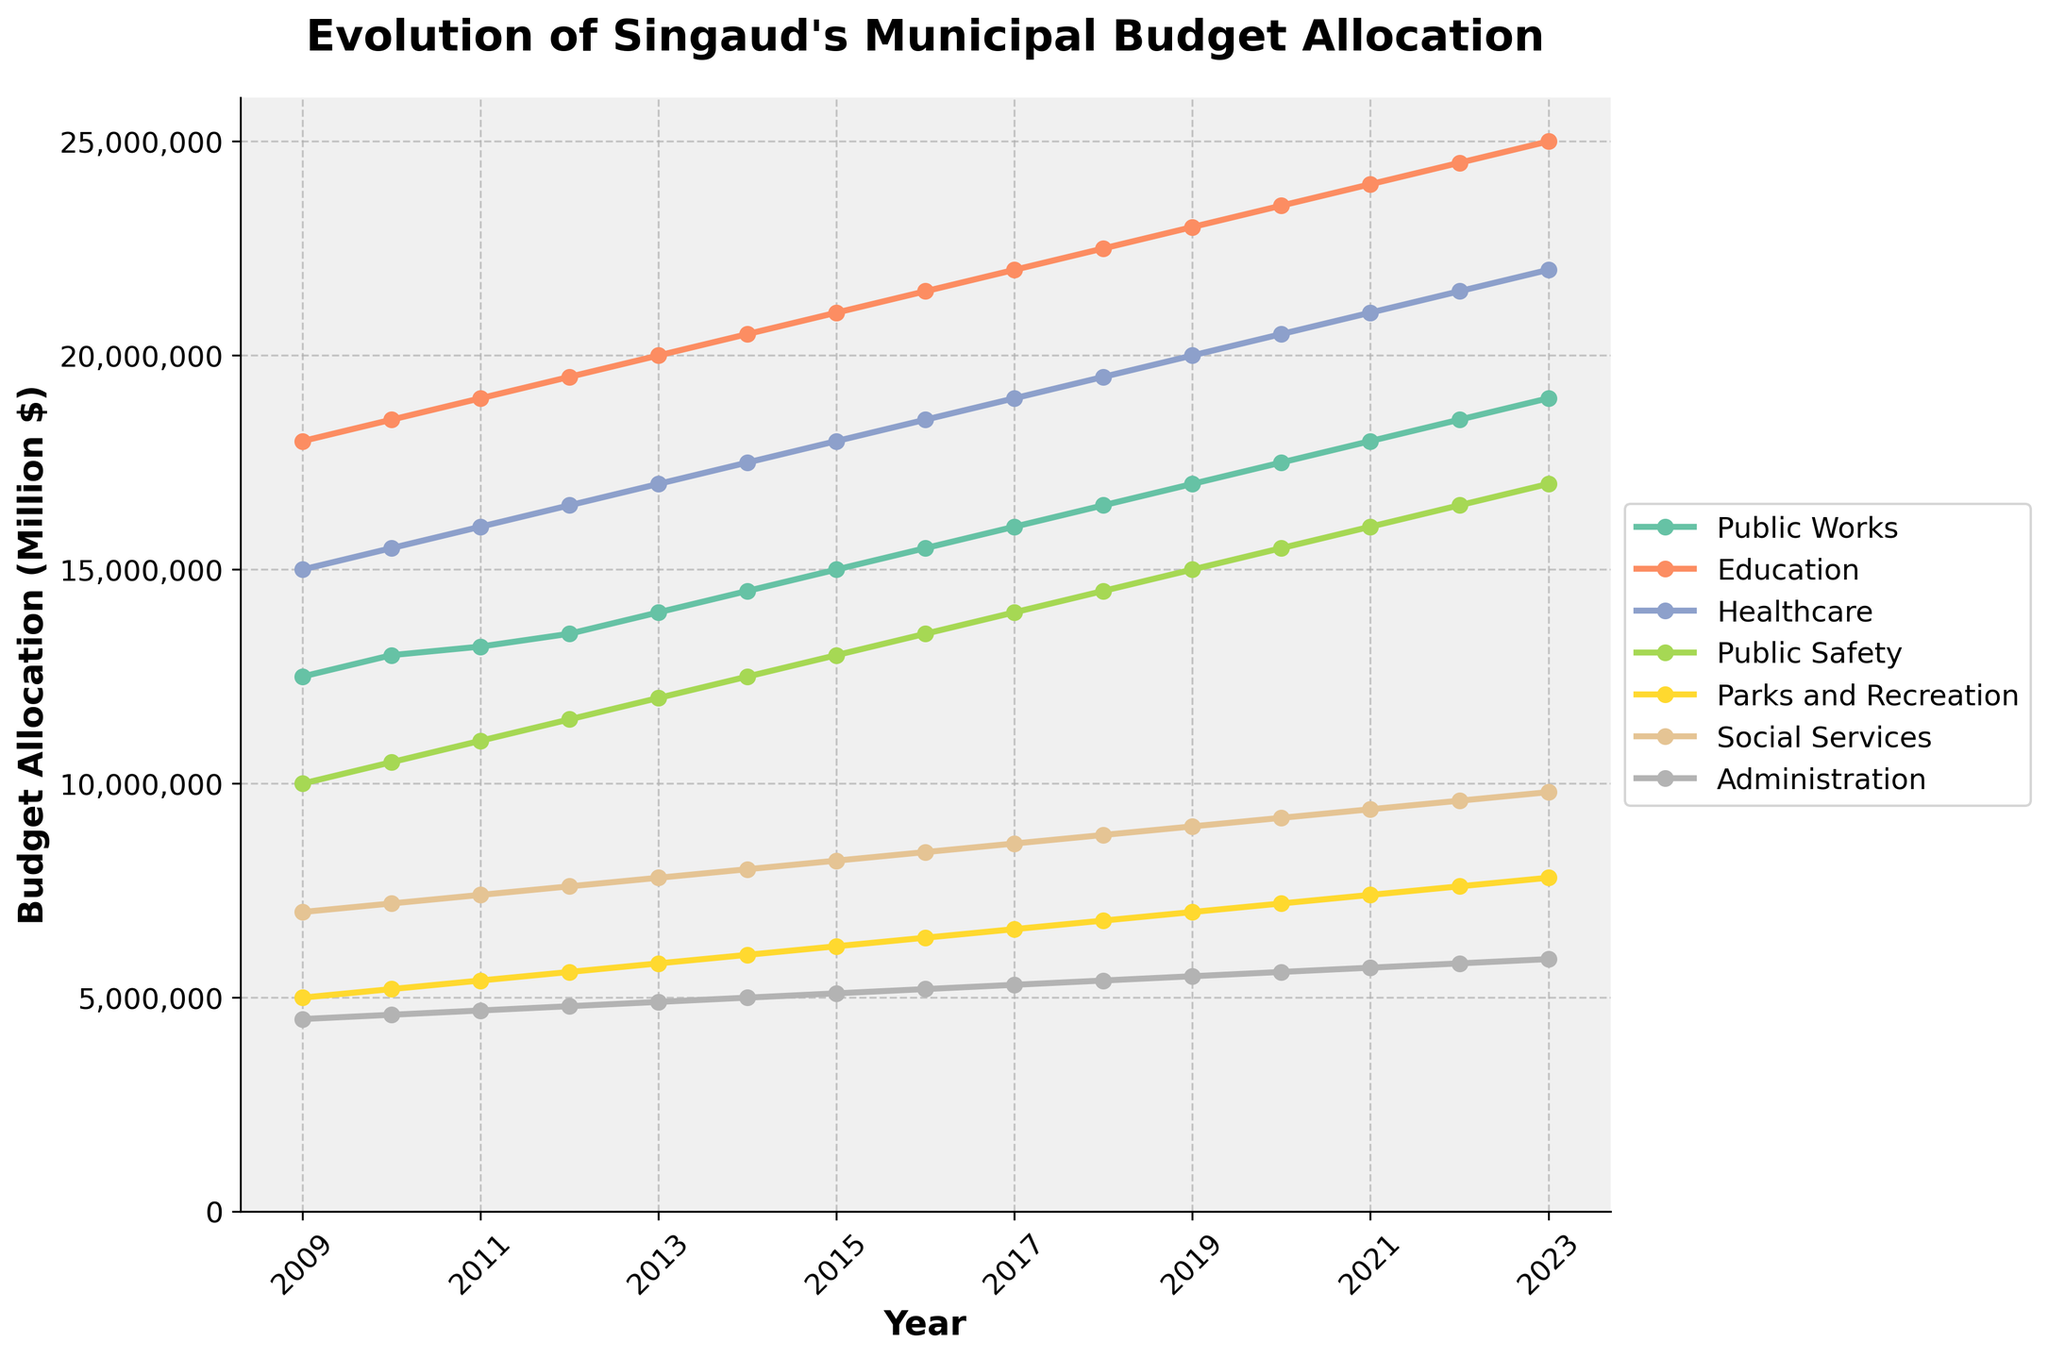What's the trend in budget allocation for the Education department over the last 15 years? By visually inspecting the chart, we can see that the line representing the Education department consistently rises from 2009 to 2023, indicating a steady increase in budget allocation.
Answer: Steady increase Which department had the smallest budget allocation in 2023 and what was the amount? In the chart, the line for Administration is the lowest among all departments in 2023. The budget allocation is at its endpoint denoted on the y-axis at approximately $5.9 million.
Answer: Administration, $5.9 million By how much did the Healthcare budget change from 2009 to 2023? Referencing the endpoints on the Healthcare line, the budget in 2009 starts at $15,000,000 and in 2023 it is $22,000,000. The difference is $22,000,000 - $15,000,000 = $7,000,000.
Answer: $7,000,000 Comparing the budgets for Public Safety and Social Services in 2016, which one was higher and by how much? In the chart, the Public Safety budget in 2016 is $13,500,000 and the Social Services budget is $8,400,000. The difference is $13,500,000 - $8,400,000 = $5,100,000.
Answer: Public Safety, $5,100,000 What is the average annual budget increase for the Public Works department from 2009 to 2023? The Public Works budget increases from $12,500,000 in 2009 to $19,000,000 in 2023. Spread over 15 years, the average annual increase is ($19,000,000 - $12,500,000) / 15 = $6,500,000 / 15 = $433,333.33.
Answer: $433,333.33 Which department had the largest increase in budget allocation from 2017 to 2023? Looking at the chart, the Parks and Recreation line shows a significant rise from roughly $6,600,000 in 2017 to $7,800,000 in 2023. The increase is $7,800,000 - $6,600,000 = $1,200,000. Upon checking, no other department shows a larger increase in this period.
Answer: Parks and Recreation In which year did the Public Safety department's budget hit $14,000,000? Observing the intercepts of the Public Safety line, it crosses the $14,000,000 mark in 2017 on the x-axis, as indicated by the parallel tick marks.
Answer: 2017 Which department had the least growth in budget allocation over the 15 years? By comparing the slopes of all the lines, the Administration department shows the least steep increase from $4,500,000 in 2009 to $5,900,000 in 2023, indicating the least growth of $5,900,000 - $4,500,000 = $1,400,000 over 15 years.
Answer: Administration 